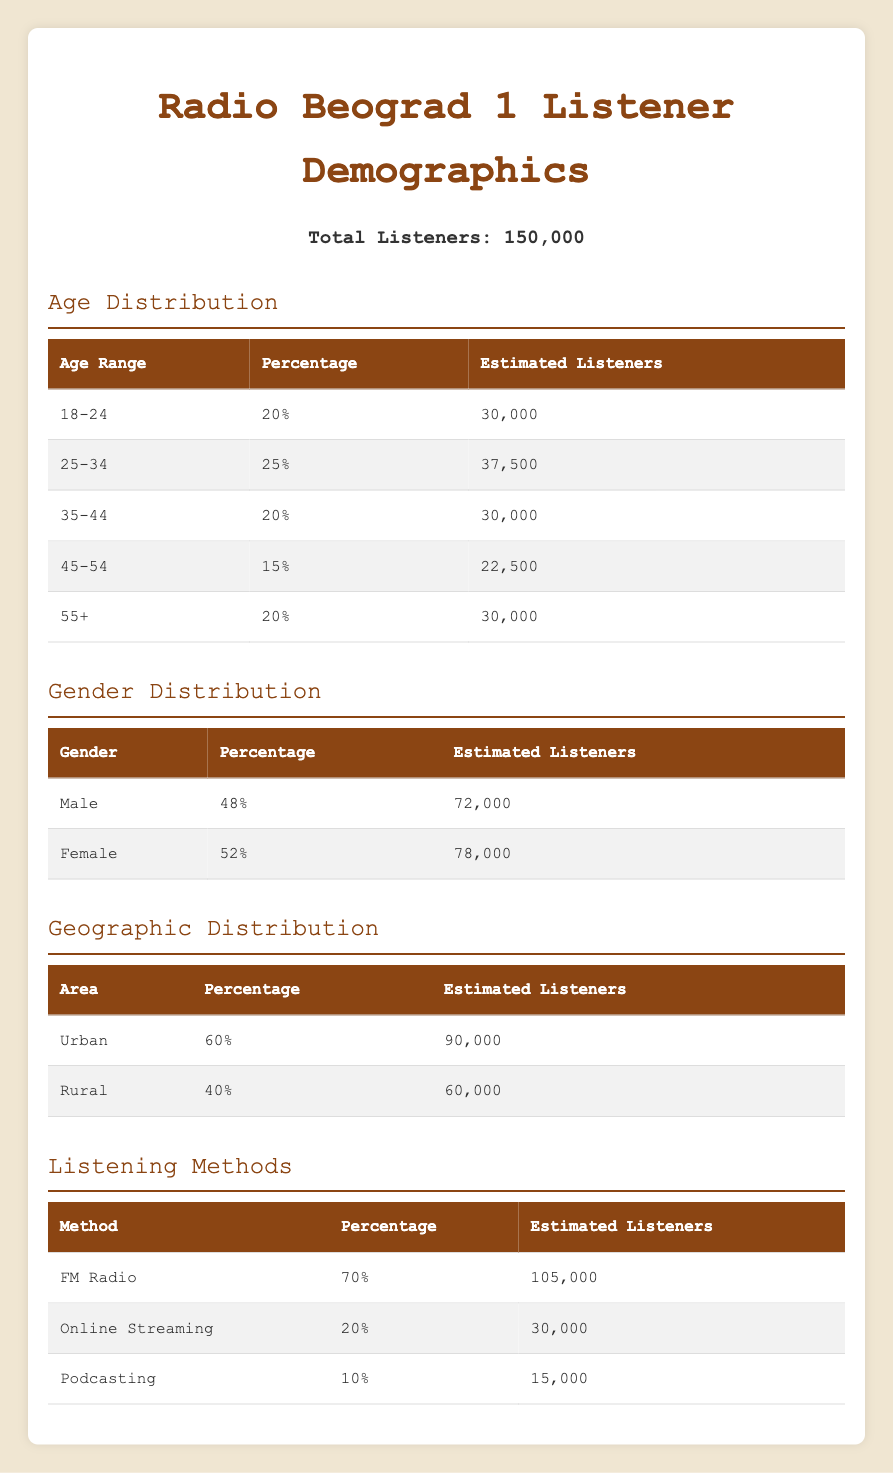What percentage of listeners are aged 25-34? The table shows the percentage for the age group 25-34 directly in the age distribution section, which is 25%.
Answer: 25% How many estimated listeners are aged 45-54? Referring to the age distribution section, for the age range 45-54, the estimated listeners are listed as 22,500.
Answer: 22,500 What is the gender distribution of listeners in percentage? The gender distribution section lists 48% male and 52% female listeners clearly, showing the split between genders.
Answer: 48% male and 52% female Is it true that more than half of the listeners tune in through FM radio? The listening methods section shows FM radio accounts for 70% of listeners, which is indeed more than half.
Answer: Yes What is the estimated number of rural listeners compared to urban listeners? The table indicates urban listeners are estimated at 90,000 and rural listeners at 60,000. To compare, urban listeners (90,000) are greater by 30,000 than rural listeners (60,000).
Answer: Urban listeners exceed rural listeners by 30,000 What percentage of listeners are using online streaming? In the listening methods section, online streaming is listed as 20% of the total listeners. This provides a clear understanding of its usage.
Answer: 20% What is the total percentage of listeners aged 35 and above? The age distribution shows the following age groups: 35-44 (20%), 45-54 (15%), and 55+ (20%). Adding these percentages: 20% + 15% + 20% = 55%. Thus, the total percentage of listeners aged 35 and above is 55%.
Answer: 55% How many more female listeners are there compared to male listeners? From the gender distribution, male listeners are estimated at 72,000, and female listeners are 78,000. The difference is calculated as 78,000 - 72,000 = 6,000, indicating there are 6,000 more female listeners.
Answer: 6,000 more female listeners What is the combined percentage of listeners who prefer podcasting and online streaming? The listening methods section shows podcasting at 10% and online streaming at 20%. Combining these gives 10% + 20% = 30%. Thus, the combined percentage is 30%.
Answer: 30% 